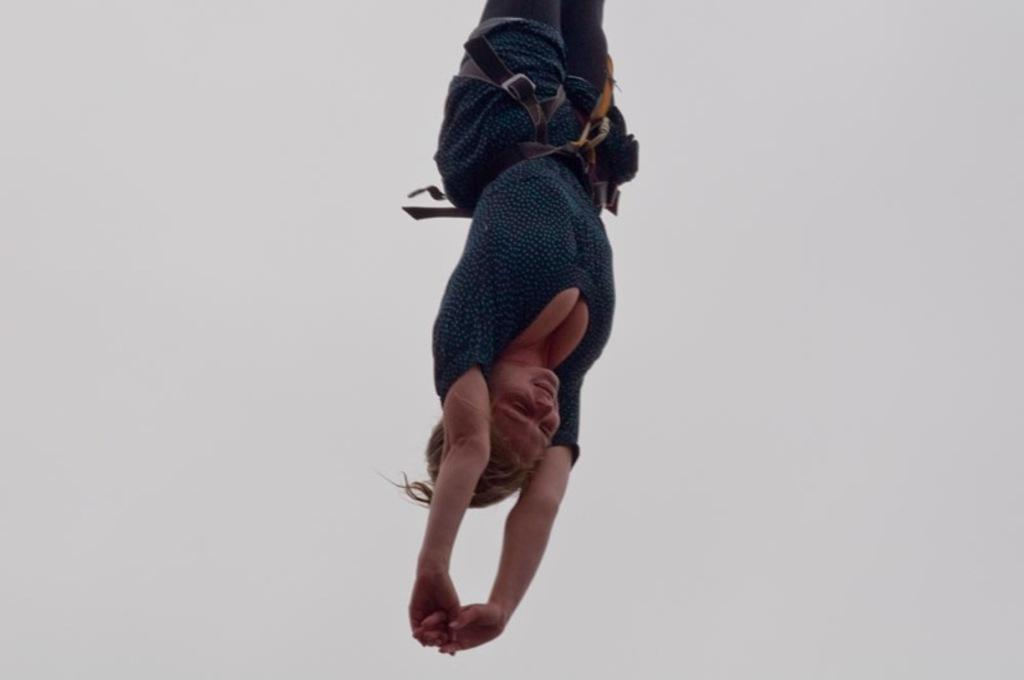Who or what is the main subject of the image? There is a person in the image. What is the person wearing in the image? The person is wearing a blue and black color dress and a belt. What is the color of the background in the image? The background of the image is white. How many spiders are crawling on the canvas in the image? There are no spiders or canvas present in the image. Is the person in the image swimming in the background? There is no indication of swimming or a body of water in the image; the person is standing on a white background. 